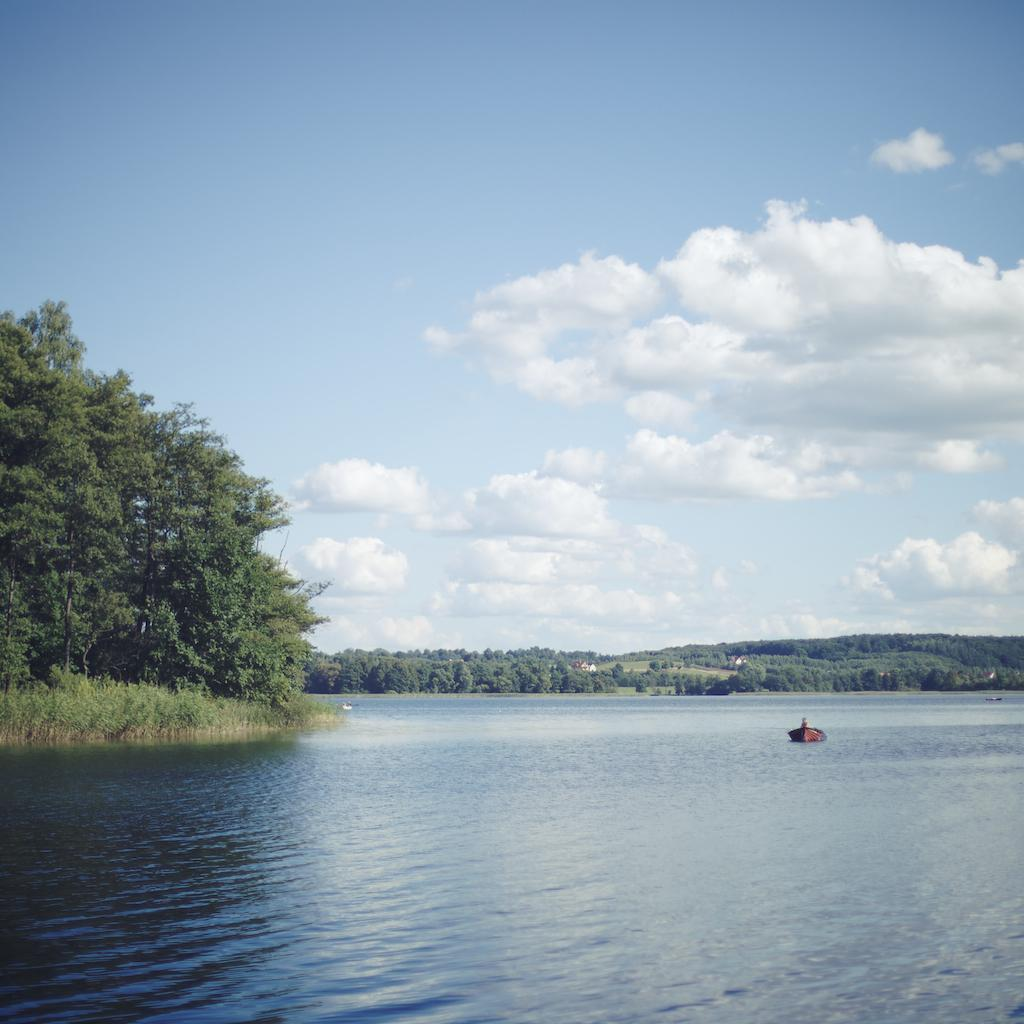What is the main feature in the middle of the image? There is a river in the middle of the image. What is located in the river? There is a boat in the river. What can be seen in the background of the image? There are trees in the background of the image. What is visible at the top of the image? The sky is visible at the top of the image. Is the manager of the river visible in the image? There is no mention of a manager in the image, and the image does not depict a person in charge of the river. 